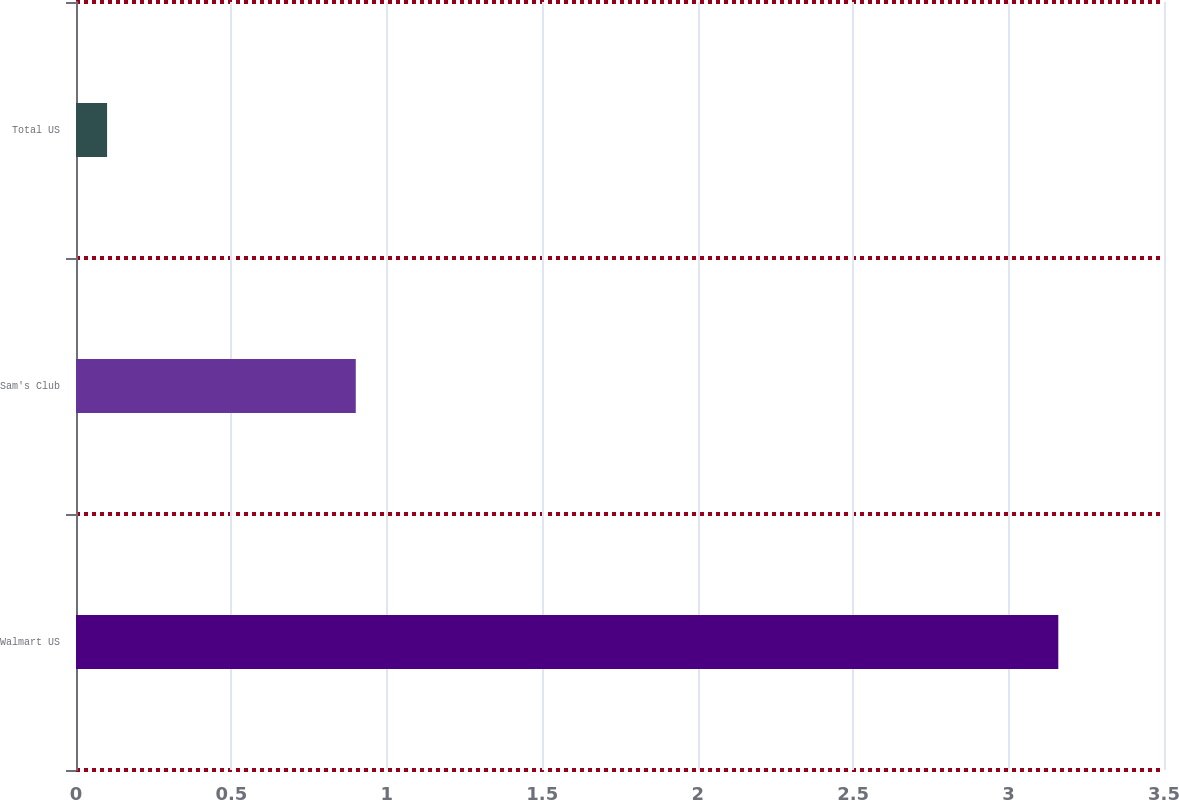Convert chart to OTSL. <chart><loc_0><loc_0><loc_500><loc_500><bar_chart><fcel>Walmart US<fcel>Sam's Club<fcel>Total US<nl><fcel>3.16<fcel>0.9<fcel>0.1<nl></chart> 